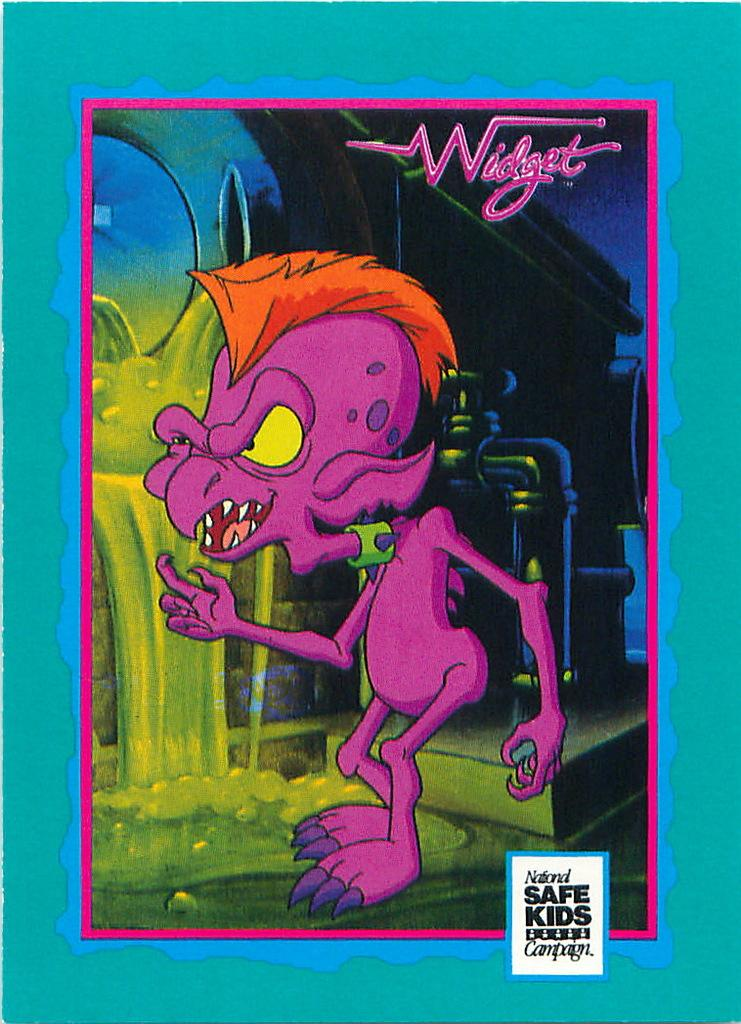Provide a one-sentence caption for the provided image. a poster of a purple monster named widget. 